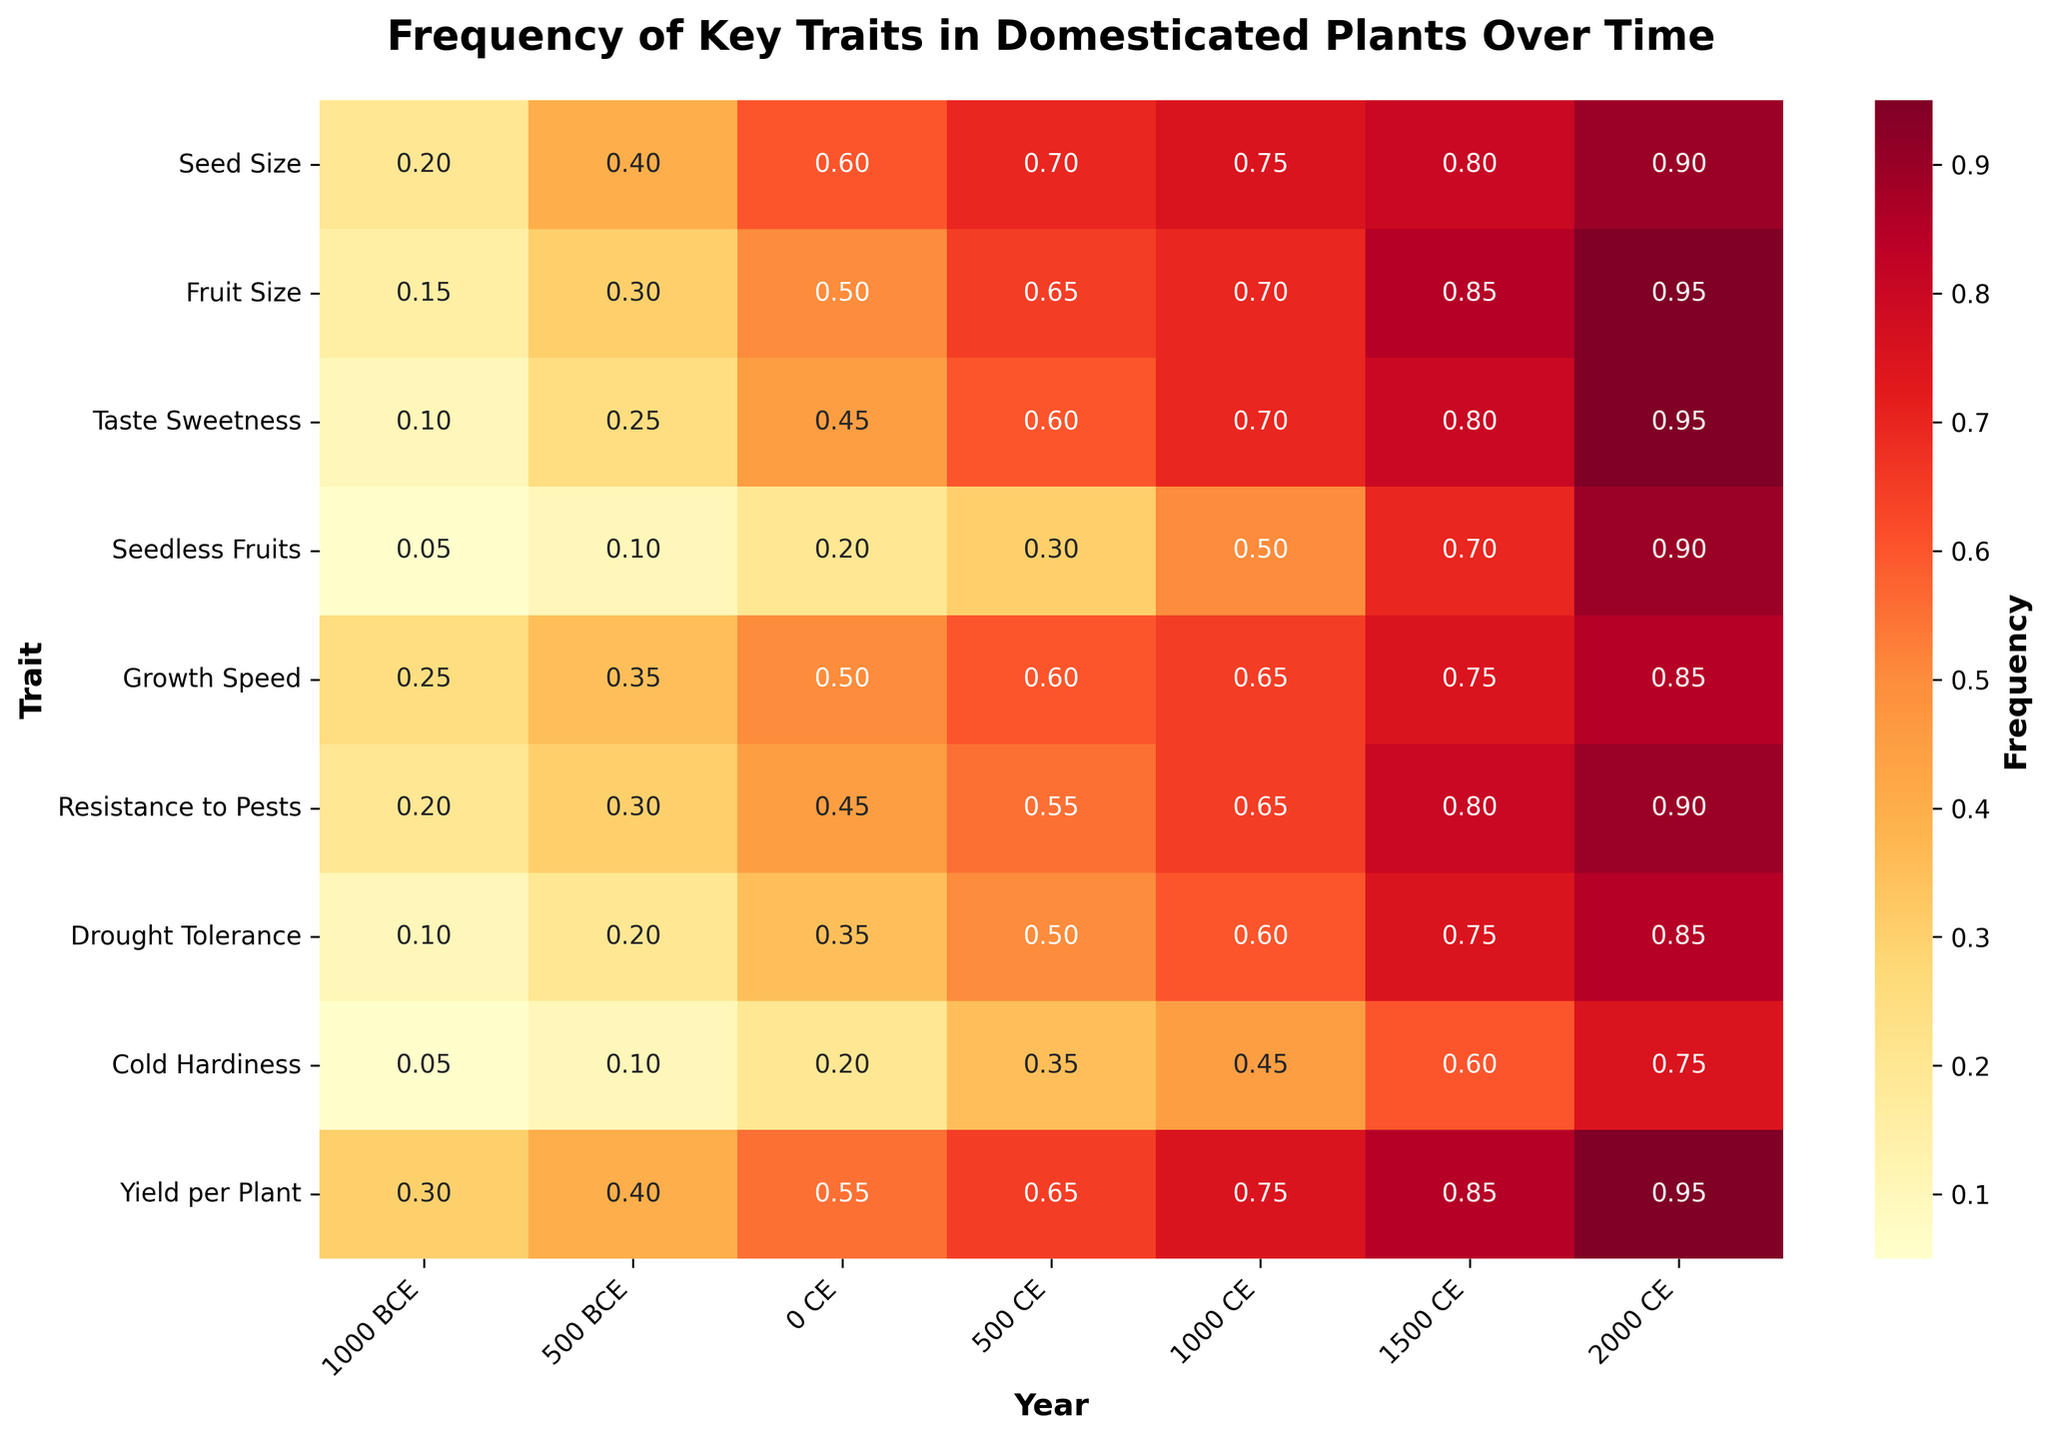What is the title of the heatmap? The title is written at the top of the heatmap.
Answer: Frequency of Key Traits in Domesticated Plants Over Time Which trait has shown the most significant increase in frequency from 1000 BCE to 2000 CE? Compare the changes in frequency for all traits from 1000 BCE to 2000 CE. Seedless Fruits increased from 0.05 to 0.9, the largest increase.
Answer: Seedless Fruits Between which years did Seed Size show the least growth in frequency? Check the values for Seed Size across all years and find the smallest increase. The increase from 1000 BCE (0.2) to 500 BCE (0.4) is 0.2, which is the smallest.
Answer: 1000 BCE to 500 BCE Which traits had a frequency of 0.6 in the year 500 CE? Look at the 500 CE column and identify which rows have a value of 0.6. Taste Sweetness, Growth Speed, and Drought Tolerance have values of 0.6.
Answer: Taste Sweetness, Growth Speed, Drought Tolerance What is the average frequency of Yield per Plant across all years? Add the values for Yield per Plant: 0.3 + 0.4 + 0.55 + 0.65 + 0.75 + 0.85 + 0.95. Then divide by 7 (the number of years). The sum is 4.45; the average is 4.45/7.
Answer: 0.64 Which year showed the highest average frequency across all traits? Calculate the average frequency for each year by summing the values for all traits and dividing by the number of traits (9). Compare these averages to find the highest.
Answer: 2000 CE How much did Taste Sweetness improve from 0 CE to 1000 CE? Subtract the frequency of Taste Sweetness in 0 CE (0.45) from its frequency in 1000 CE (0.7).
Answer: 0.25 Which trait had a frequency of 0.9 in 2000 CE? Look at the 2000 CE column and find the trait corresponding to the value 0.9.
Answer: Seed Size, Seedless Fruits, Resistance to Pests Compare the frequency changes of Fruit Size and Growth Speed from 500 BCE to 1500 CE. Which had a higher increase? Calculate the frequency change for each trait over the period. Fruit Size increases from 0.3 to 0.85 (0.55), and Growth Speed increases from 0.35 to 0.75 (0.4). Fruit Size has the higher increase.
Answer: Fruit Size What was the frequency of Cold Hardiness in the year 0 CE? Find the value corresponding to Cold Hardiness for the year 0 CE in the heatmap.
Answer: 0.2 